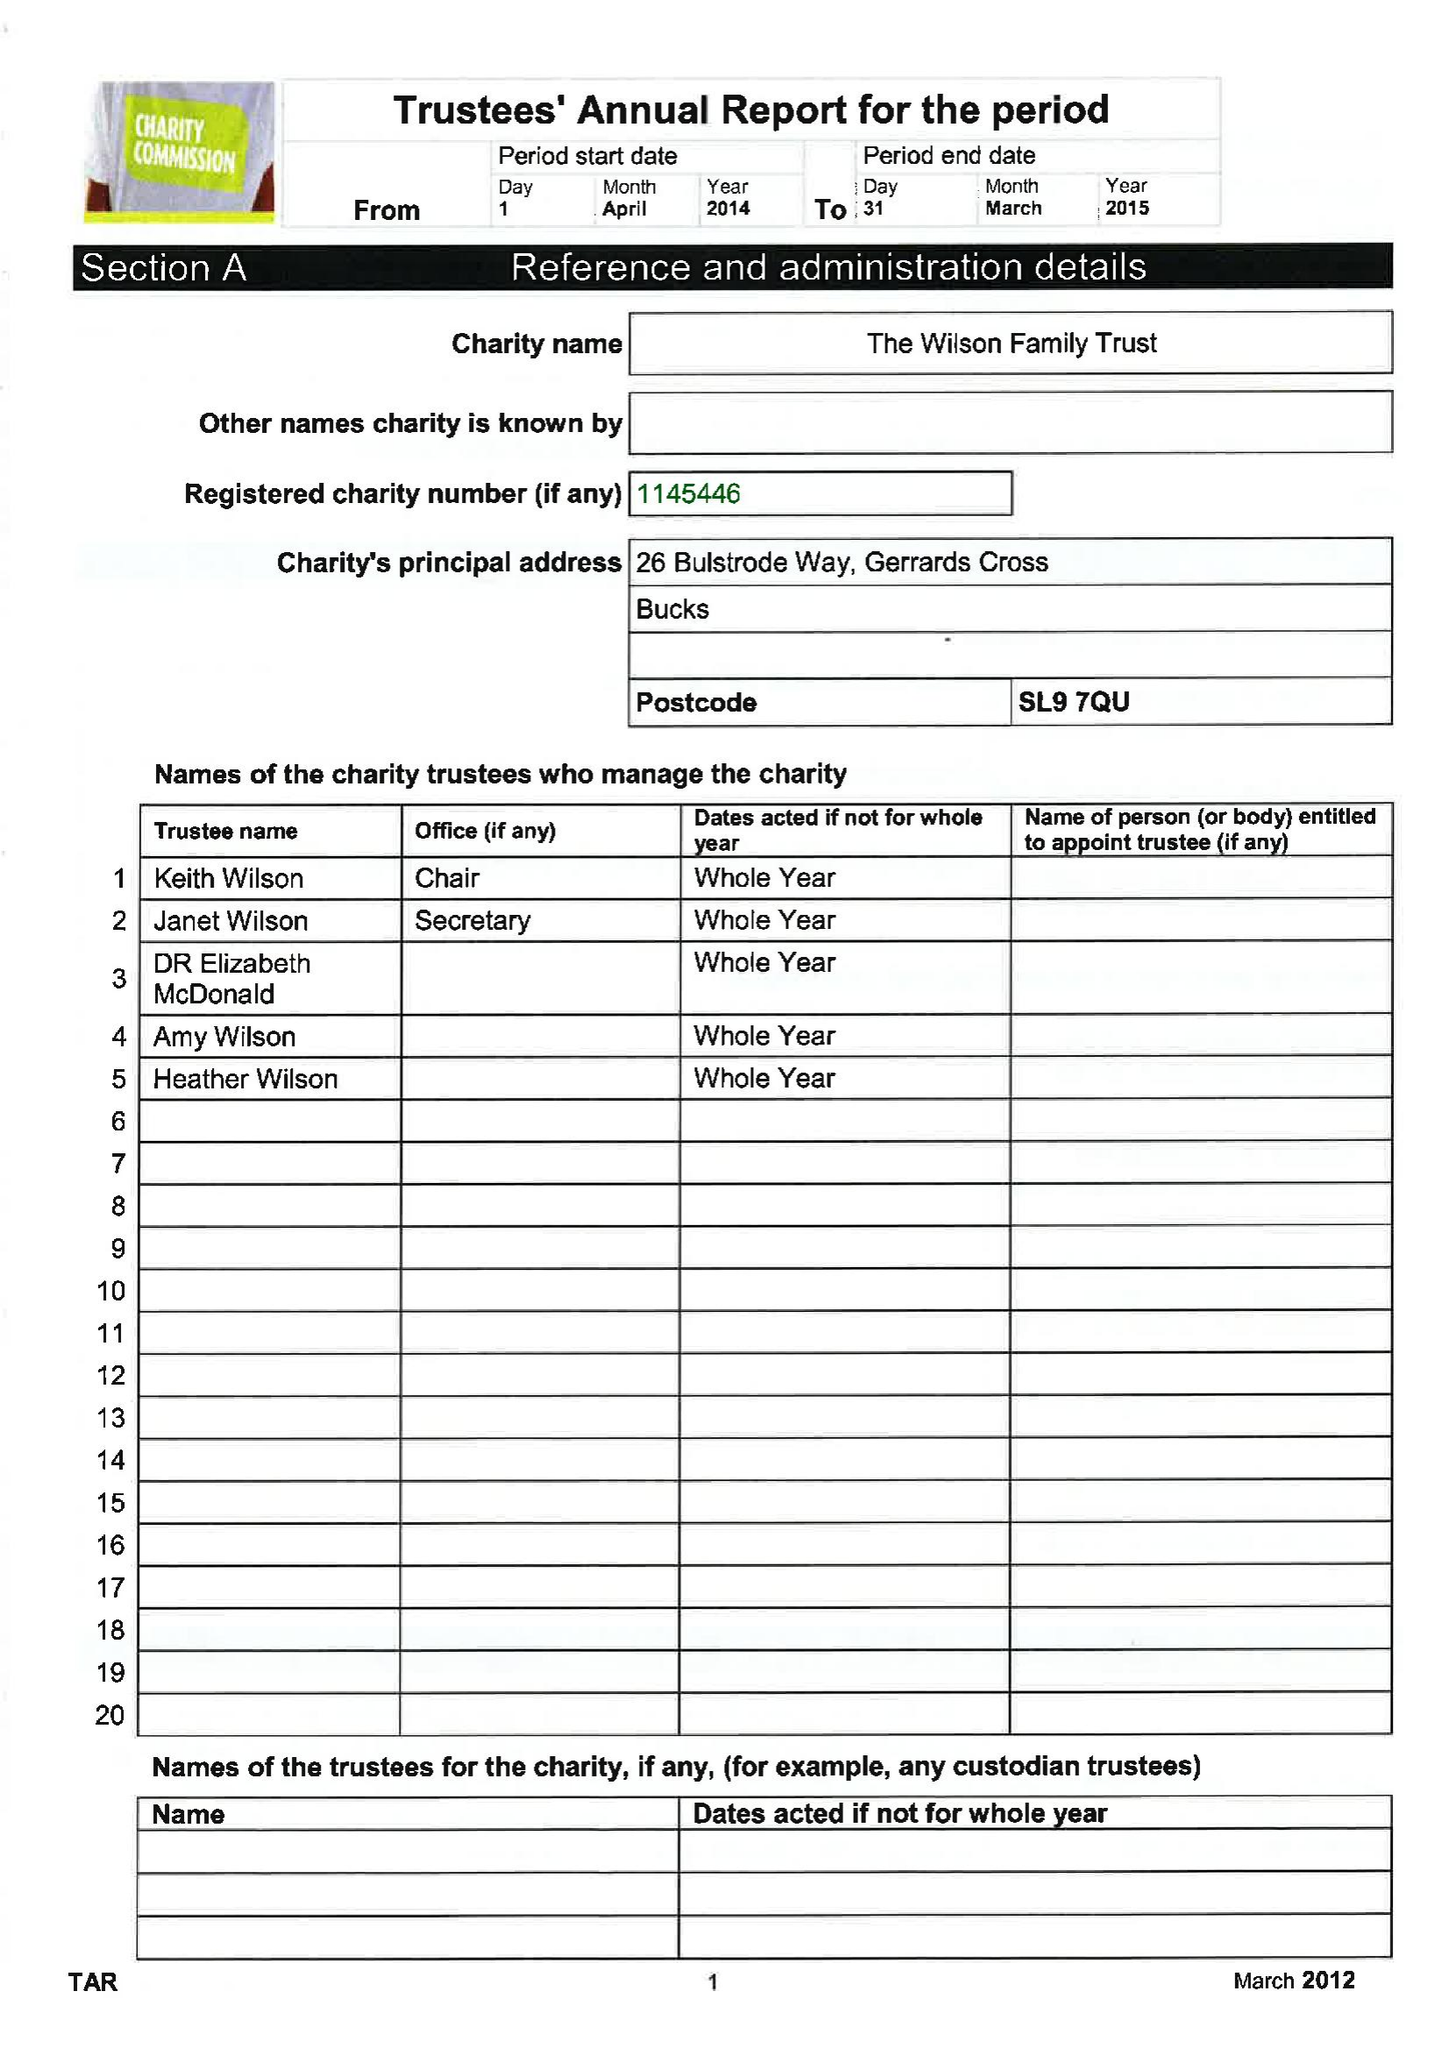What is the value for the charity_name?
Answer the question using a single word or phrase. The Wilson Family Trust 